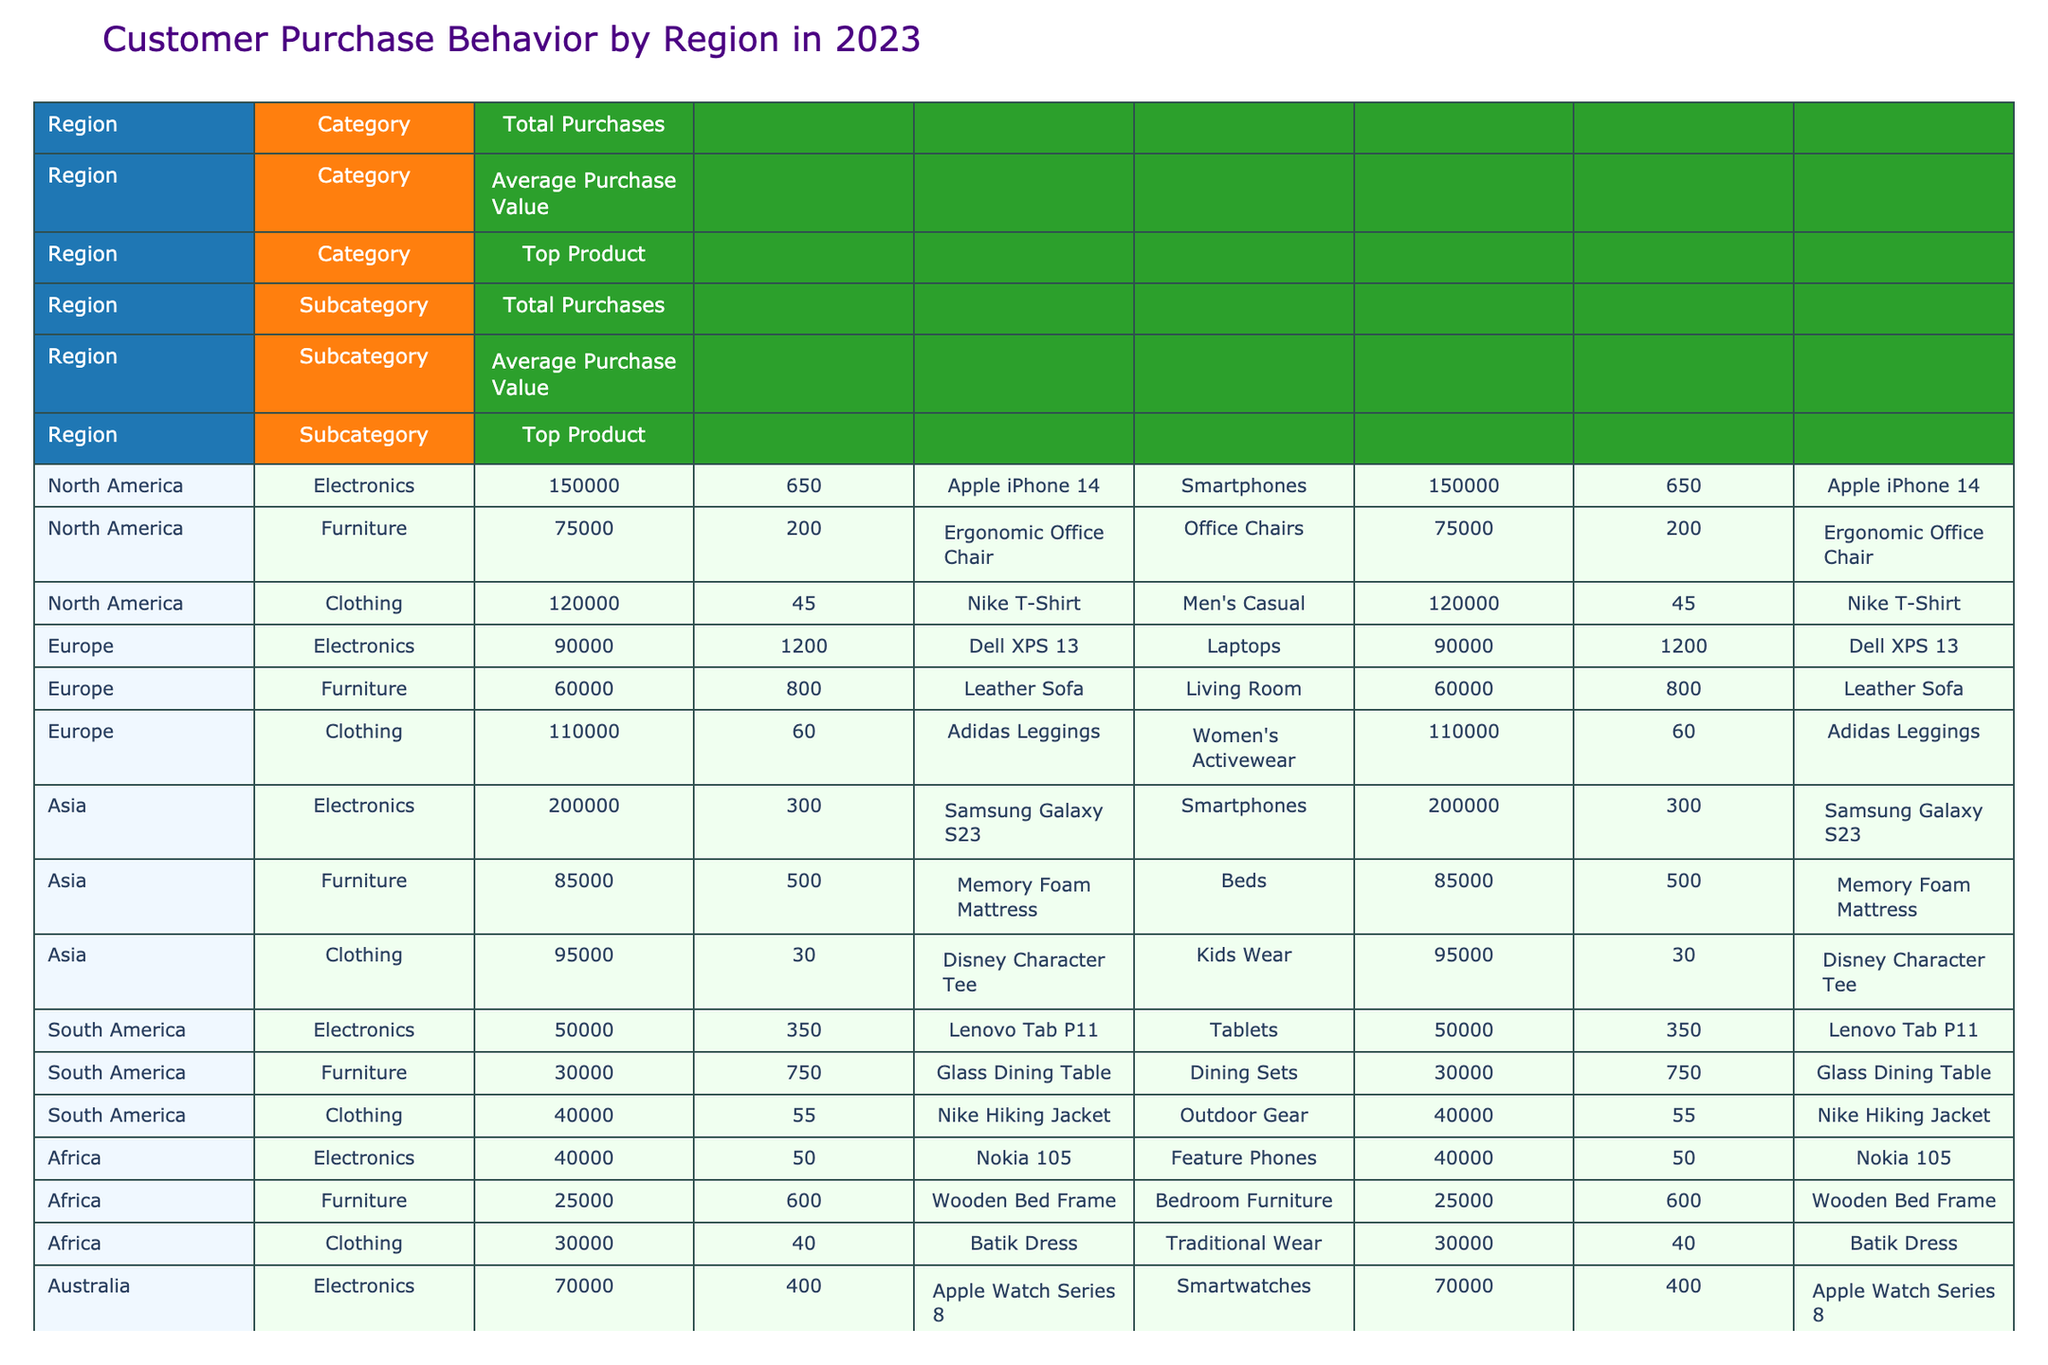What is the total number of purchases for electronics in Asia? In the table, the total purchases for electronics in Asia is listed under the 'Total Purchases' column for the 'Smartphones' subcategory, which amounts to 200,000.
Answer: 200000 Which region has the highest average purchase value for furniture? Looking at the average purchase value for furniture across the regions in the table, we can see that the value for 'Living Room' in Europe is 800, while in Asia, the 'Beds' subcategory is 500, and these are the highest values listed for furniture. Therefore, Europe has the highest average purchase value for furniture.
Answer: Europe Is the top product for clothing in North America the same as in Europe? The top product for clothing in North America is 'Men's Casual' (Nike T-Shirt), and in Europe, it is 'Women's Activewear' (Adidas Leggings). Since the two products are different, the answer is no.
Answer: No What is the combined total purchases for clothing in South America and Africa? Total purchases for clothing in South America is 40,000 and in Africa it is 30,000. Adding these together, 40,000 + 30,000 equals 70,000, so the combined total purchases for clothing in South America and Africa is 70,000.
Answer: 70000 Does Asia have more total purchases in electronics than North America? For electronics, North America has 'Smartphones' total purchases of 150,000, while Asia has 'Smartphones' total purchases of 200,000. Since 200,000 is greater than 150,000, the statement is true.
Answer: Yes Which subcategory has the highest total purchases in South America? In South America, we can examine the total purchases for each subcategory: electronics (50,000), furniture (30,000), and clothing (40,000). The highest amount is 50,000 for electronics.
Answer: Electronics What is the average purchase value for outdoor furniture in Australia? The average purchase value listed under outdoor furniture in Australia is 900. This value directly corresponds to the relevant entry in the table.
Answer: 900 What product has the highest average purchase value among all categories in the North America region? Based on the table data, the average purchase values for North America are: 'Smartphones' (650), 'Office Chairs' (200), and 'Men's Casual' (45). The highest average among these values is 650 for 'Smartphones', making it the highest average purchase value product in North America.
Answer: Apple iPhone 14 